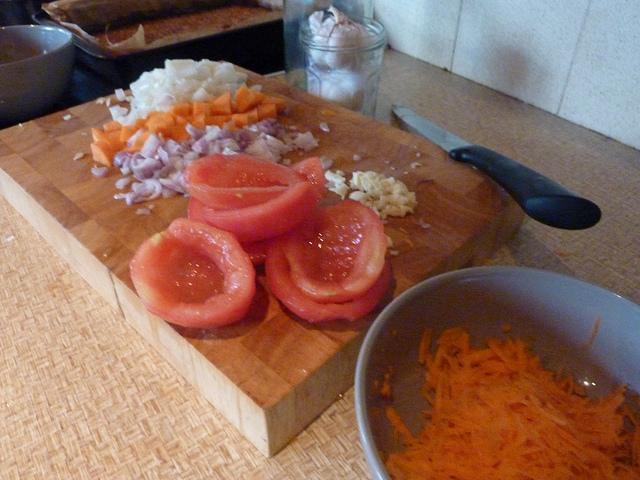How many cups are there?
Give a very brief answer. 1. How many bowls are there?
Give a very brief answer. 2. How many carrots can be seen?
Give a very brief answer. 1. 